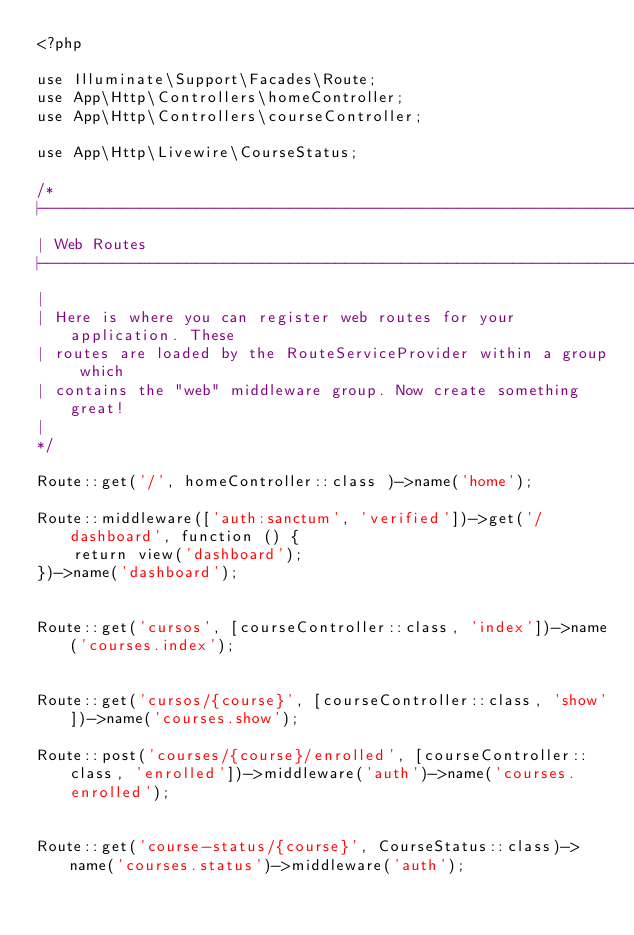Convert code to text. <code><loc_0><loc_0><loc_500><loc_500><_PHP_><?php

use Illuminate\Support\Facades\Route;
use App\Http\Controllers\homeController;
use App\Http\Controllers\courseController;

use App\Http\Livewire\CourseStatus;

/*
|--------------------------------------------------------------------------
| Web Routes
|--------------------------------------------------------------------------
|
| Here is where you can register web routes for your application. These
| routes are loaded by the RouteServiceProvider within a group which
| contains the "web" middleware group. Now create something great!
|
*/

Route::get('/', homeController::class )->name('home');

Route::middleware(['auth:sanctum', 'verified'])->get('/dashboard', function () {
    return view('dashboard');
})->name('dashboard');


Route::get('cursos', [courseController::class, 'index'])->name('courses.index');


Route::get('cursos/{course}', [courseController::class, 'show'])->name('courses.show');

Route::post('courses/{course}/enrolled', [courseController::class, 'enrolled'])->middleware('auth')->name('courses.enrolled');


Route::get('course-status/{course}', CourseStatus::class)->name('courses.status')->middleware('auth');</code> 